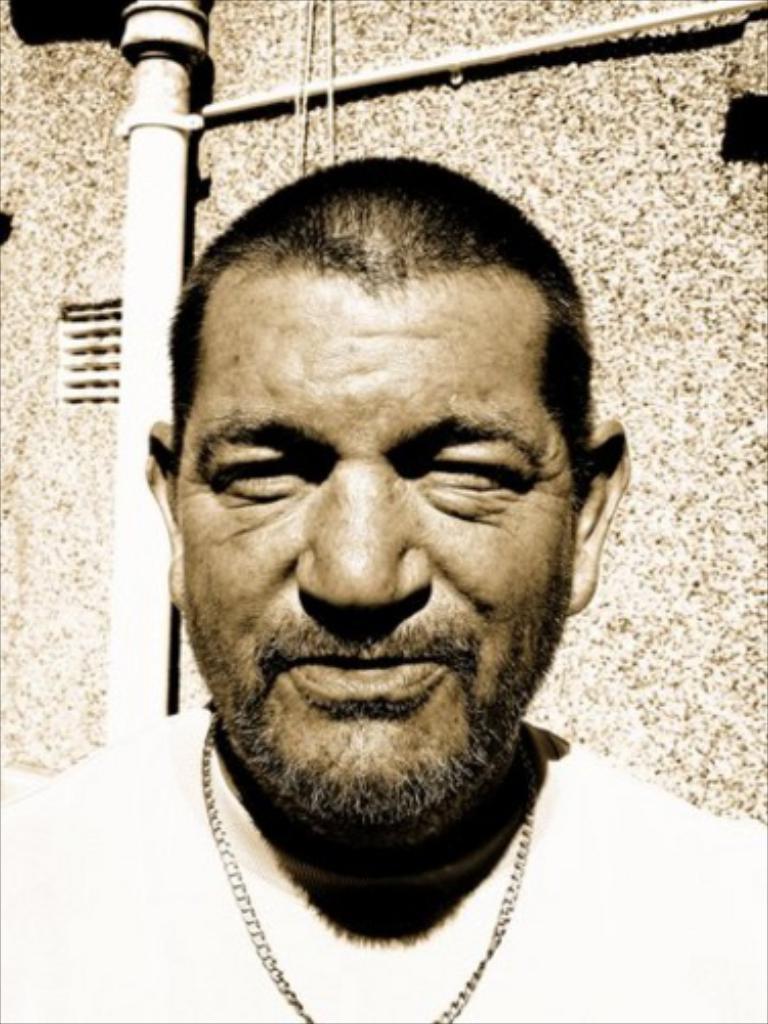In one or two sentences, can you explain what this image depicts? In this image, I can see the man standing and smiling. In the background, that looks like a pipe, which is attached to the building wall. 